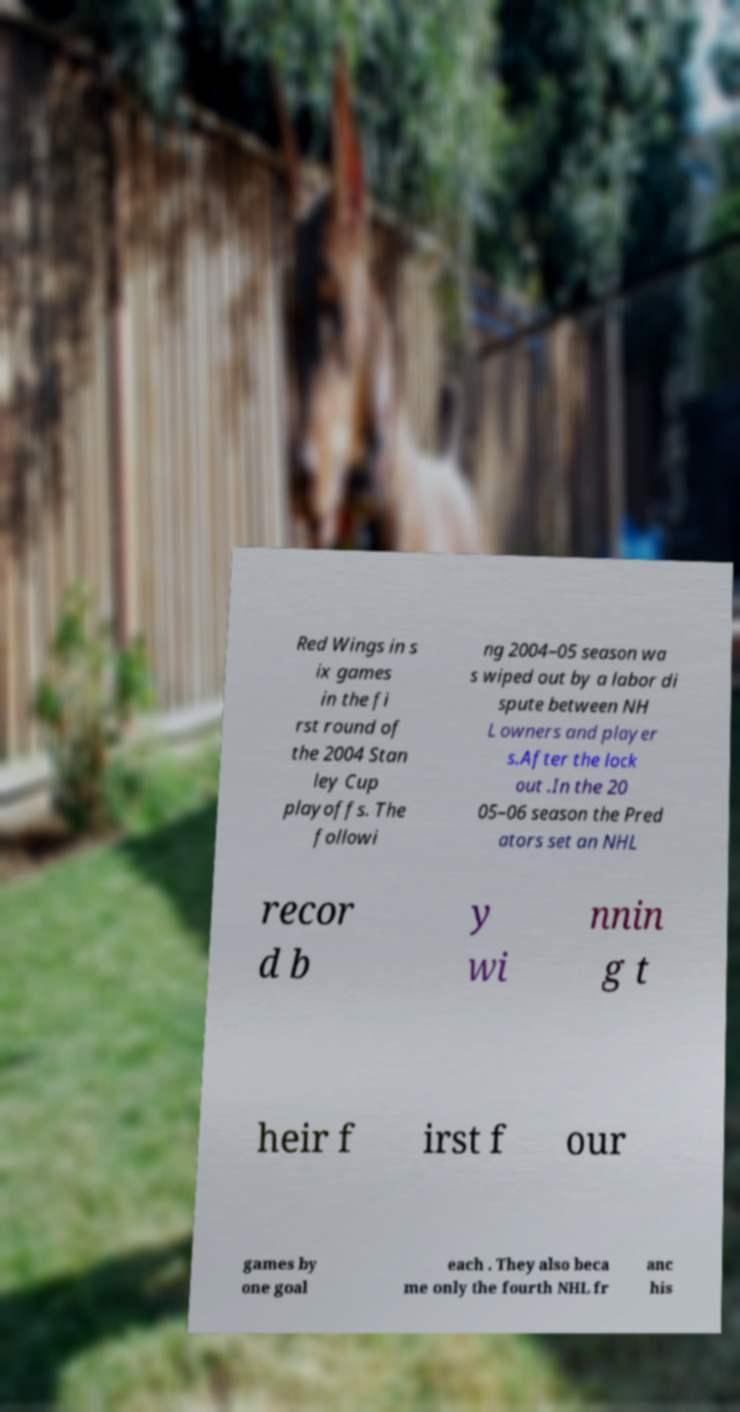There's text embedded in this image that I need extracted. Can you transcribe it verbatim? Red Wings in s ix games in the fi rst round of the 2004 Stan ley Cup playoffs. The followi ng 2004–05 season wa s wiped out by a labor di spute between NH L owners and player s.After the lock out .In the 20 05–06 season the Pred ators set an NHL recor d b y wi nnin g t heir f irst f our games by one goal each . They also beca me only the fourth NHL fr anc his 